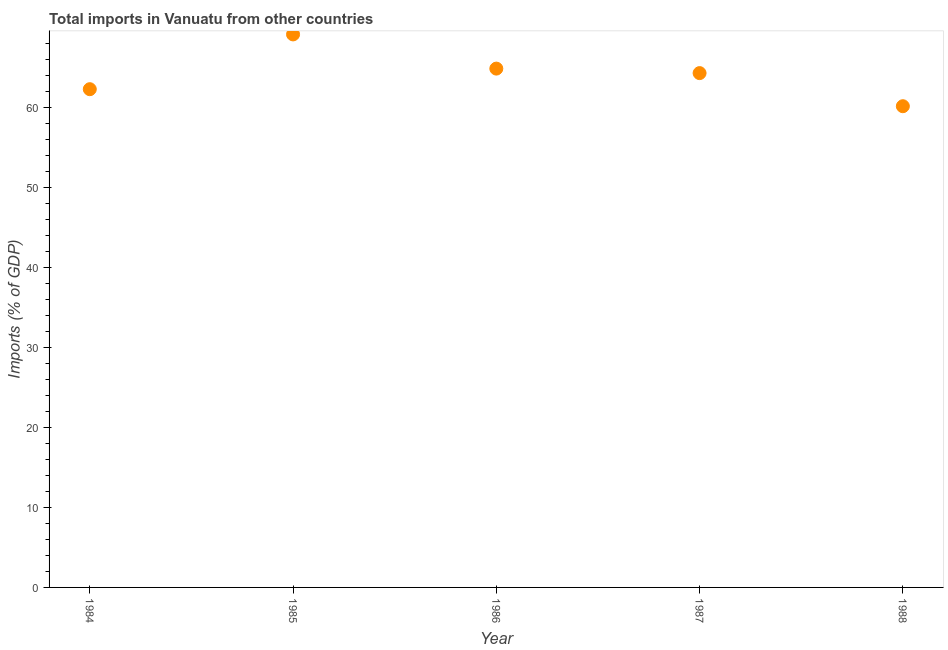What is the total imports in 1985?
Your answer should be very brief. 69.08. Across all years, what is the maximum total imports?
Your answer should be very brief. 69.08. Across all years, what is the minimum total imports?
Your answer should be compact. 60.11. In which year was the total imports minimum?
Provide a succinct answer. 1988. What is the sum of the total imports?
Your answer should be compact. 320.5. What is the difference between the total imports in 1984 and 1988?
Offer a terse response. 2.13. What is the average total imports per year?
Your answer should be very brief. 64.1. What is the median total imports?
Your response must be concise. 64.25. In how many years, is the total imports greater than 60 %?
Offer a very short reply. 5. Do a majority of the years between 1986 and 1987 (inclusive) have total imports greater than 18 %?
Your response must be concise. Yes. What is the ratio of the total imports in 1984 to that in 1986?
Your answer should be compact. 0.96. Is the total imports in 1984 less than that in 1985?
Make the answer very short. Yes. What is the difference between the highest and the second highest total imports?
Your response must be concise. 4.27. Is the sum of the total imports in 1984 and 1988 greater than the maximum total imports across all years?
Your answer should be very brief. Yes. What is the difference between the highest and the lowest total imports?
Give a very brief answer. 8.97. In how many years, is the total imports greater than the average total imports taken over all years?
Your answer should be very brief. 3. Does the total imports monotonically increase over the years?
Your answer should be compact. No. How many dotlines are there?
Offer a terse response. 1. How many years are there in the graph?
Give a very brief answer. 5. What is the difference between two consecutive major ticks on the Y-axis?
Offer a very short reply. 10. Are the values on the major ticks of Y-axis written in scientific E-notation?
Provide a short and direct response. No. Does the graph contain any zero values?
Ensure brevity in your answer.  No. What is the title of the graph?
Your response must be concise. Total imports in Vanuatu from other countries. What is the label or title of the Y-axis?
Your response must be concise. Imports (% of GDP). What is the Imports (% of GDP) in 1984?
Your answer should be very brief. 62.24. What is the Imports (% of GDP) in 1985?
Provide a succinct answer. 69.08. What is the Imports (% of GDP) in 1986?
Your answer should be compact. 64.81. What is the Imports (% of GDP) in 1987?
Your answer should be very brief. 64.25. What is the Imports (% of GDP) in 1988?
Offer a terse response. 60.11. What is the difference between the Imports (% of GDP) in 1984 and 1985?
Give a very brief answer. -6.84. What is the difference between the Imports (% of GDP) in 1984 and 1986?
Provide a short and direct response. -2.57. What is the difference between the Imports (% of GDP) in 1984 and 1987?
Keep it short and to the point. -2.01. What is the difference between the Imports (% of GDP) in 1984 and 1988?
Provide a succinct answer. 2.13. What is the difference between the Imports (% of GDP) in 1985 and 1986?
Provide a succinct answer. 4.27. What is the difference between the Imports (% of GDP) in 1985 and 1987?
Keep it short and to the point. 4.83. What is the difference between the Imports (% of GDP) in 1985 and 1988?
Your response must be concise. 8.97. What is the difference between the Imports (% of GDP) in 1986 and 1987?
Your answer should be compact. 0.56. What is the difference between the Imports (% of GDP) in 1986 and 1988?
Make the answer very short. 4.7. What is the difference between the Imports (% of GDP) in 1987 and 1988?
Keep it short and to the point. 4.14. What is the ratio of the Imports (% of GDP) in 1984 to that in 1985?
Provide a succinct answer. 0.9. What is the ratio of the Imports (% of GDP) in 1984 to that in 1986?
Provide a succinct answer. 0.96. What is the ratio of the Imports (% of GDP) in 1984 to that in 1988?
Your answer should be compact. 1.03. What is the ratio of the Imports (% of GDP) in 1985 to that in 1986?
Provide a succinct answer. 1.07. What is the ratio of the Imports (% of GDP) in 1985 to that in 1987?
Offer a very short reply. 1.07. What is the ratio of the Imports (% of GDP) in 1985 to that in 1988?
Your answer should be very brief. 1.15. What is the ratio of the Imports (% of GDP) in 1986 to that in 1987?
Ensure brevity in your answer.  1.01. What is the ratio of the Imports (% of GDP) in 1986 to that in 1988?
Offer a terse response. 1.08. What is the ratio of the Imports (% of GDP) in 1987 to that in 1988?
Your response must be concise. 1.07. 